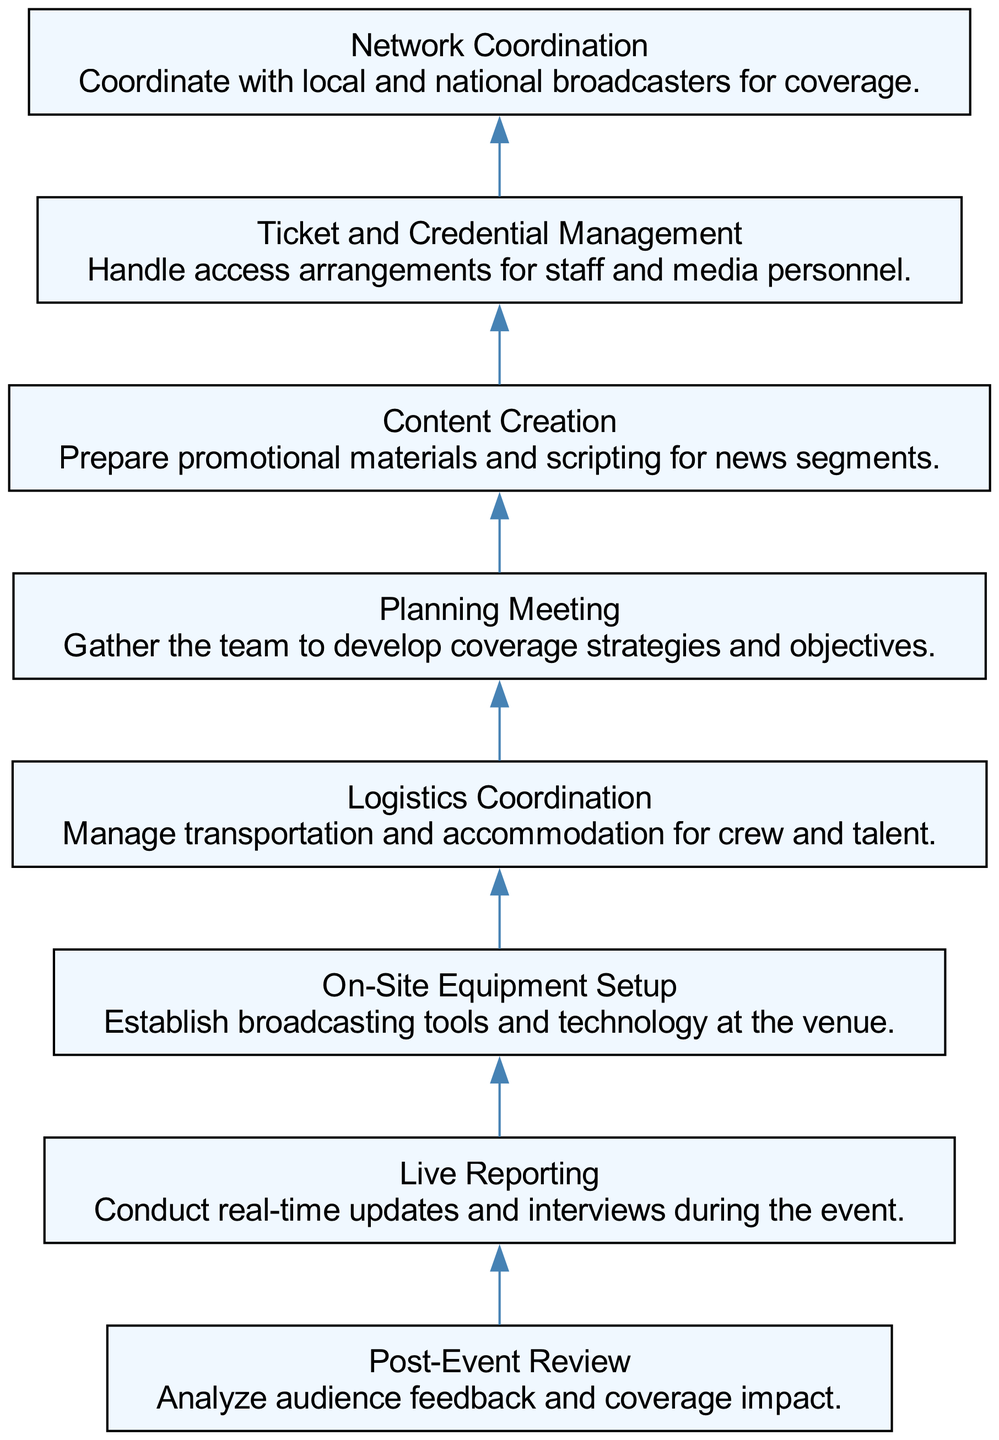What is the top node in the diagram? The top node represents the final step in the workflow, which is the Post-Event Review. This node visually appears at the highest position in the bottom-up flow chart, indicating it is the concluding phase of the event coverage process.
Answer: Post-Event Review How many nodes are present in the diagram? By counting each listed element in the bottom-up flow chart, we find that there are a total of eight nodes. Each node corresponds to a specific activity within the event coverage workflow.
Answer: 8 What is the direct predecessor of Live Reporting? To identify the predecessor of Live Reporting, we observe the diagram's flow. The immediate preceding node linked directly below Live Reporting is On-Site Equipment Setup, which indicates the preparatory step before live reporting begins.
Answer: On-Site Equipment Setup Which node is responsible for managing transportation and accommodation? The Logistics Coordination node focuses on managing transportation and accommodation for the crew and talent. This is directly indicated by the description associated with the Logistics Coordination node in the workflow.
Answer: Logistics Coordination What is the second node in the flow chart? The second node in the flow chart can be identified by observing the node sequence starting from the bottom. The first node is Planning Meeting, followed by Network Coordination as the second node. This is determined by counting the positions from the starting point.
Answer: Network Coordination Which nodes are involved in the preparation stage before the event? The nodes associated with the preparation stage before the actual event coverage is live are Planning Meeting, Logistics Coordination, Content Creation, and Ticket and Credential Management. These nodes sequentially represent the stages of planning and logistical setup before live reporting occurs.
Answer: Planning Meeting, Logistics Coordination, Content Creation, Ticket and Credential Management What is the connection direction of nodes in this diagram? The diagram illustrates a bottom-up flow, where connections are directed from lower nodes to higher nodes. This means the earlier steps in the workflow lead up to the final Post-Event Review node, showing a sequence of operations leading to review and analysis.
Answer: Bottom-up How many edges connect the nodes in the diagram? Each node, except for the topmost one, connects to the next node above it, forming a linear progression. Since there are eight nodes, there will be seven edges connecting them, indicating the flow of operations across the workflow.
Answer: 7 